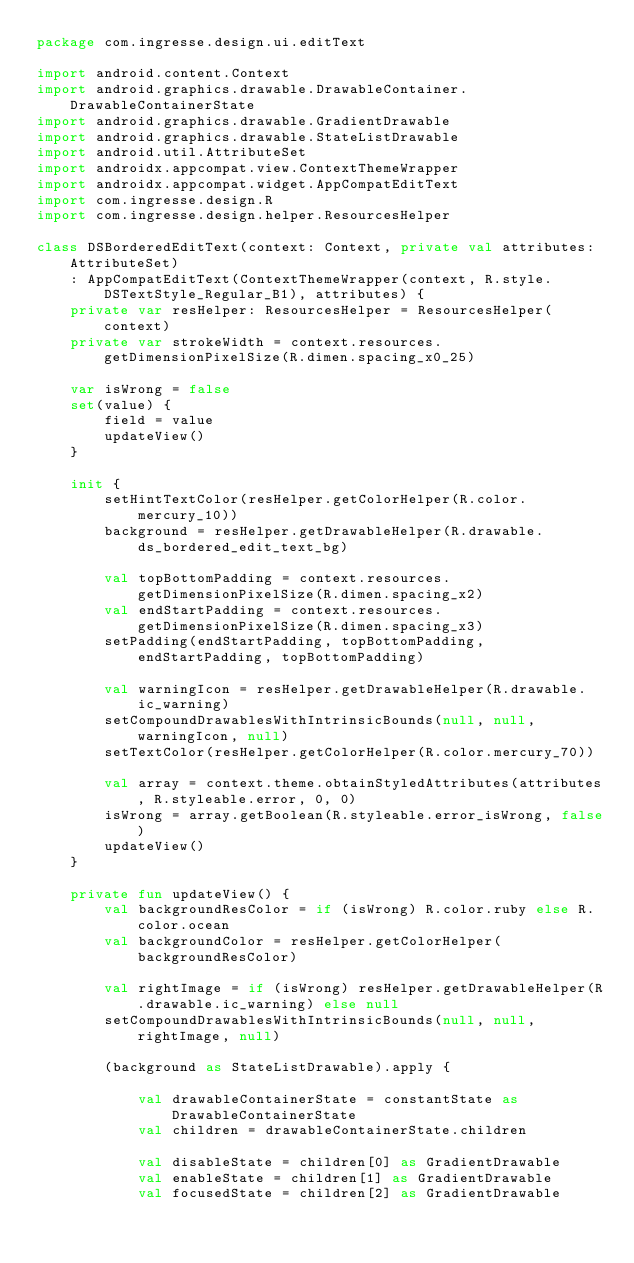Convert code to text. <code><loc_0><loc_0><loc_500><loc_500><_Kotlin_>package com.ingresse.design.ui.editText

import android.content.Context
import android.graphics.drawable.DrawableContainer.DrawableContainerState
import android.graphics.drawable.GradientDrawable
import android.graphics.drawable.StateListDrawable
import android.util.AttributeSet
import androidx.appcompat.view.ContextThemeWrapper
import androidx.appcompat.widget.AppCompatEditText
import com.ingresse.design.R
import com.ingresse.design.helper.ResourcesHelper

class DSBorderedEditText(context: Context, private val attributes: AttributeSet)
    : AppCompatEditText(ContextThemeWrapper(context, R.style.DSTextStyle_Regular_B1), attributes) {
    private var resHelper: ResourcesHelper = ResourcesHelper(context)
    private var strokeWidth = context.resources.getDimensionPixelSize(R.dimen.spacing_x0_25)

    var isWrong = false
    set(value) {
        field = value
        updateView()
    }

    init {
        setHintTextColor(resHelper.getColorHelper(R.color.mercury_10))
        background = resHelper.getDrawableHelper(R.drawable.ds_bordered_edit_text_bg)

        val topBottomPadding = context.resources.getDimensionPixelSize(R.dimen.spacing_x2)
        val endStartPadding = context.resources.getDimensionPixelSize(R.dimen.spacing_x3)
        setPadding(endStartPadding, topBottomPadding, endStartPadding, topBottomPadding)

        val warningIcon = resHelper.getDrawableHelper(R.drawable.ic_warning)
        setCompoundDrawablesWithIntrinsicBounds(null, null, warningIcon, null)
        setTextColor(resHelper.getColorHelper(R.color.mercury_70))

        val array = context.theme.obtainStyledAttributes(attributes, R.styleable.error, 0, 0)
        isWrong = array.getBoolean(R.styleable.error_isWrong, false)
        updateView()
    }

    private fun updateView() {
        val backgroundResColor = if (isWrong) R.color.ruby else R.color.ocean
        val backgroundColor = resHelper.getColorHelper(backgroundResColor)

        val rightImage = if (isWrong) resHelper.getDrawableHelper(R.drawable.ic_warning) else null
        setCompoundDrawablesWithIntrinsicBounds(null, null, rightImage, null)

        (background as StateListDrawable).apply {

            val drawableContainerState = constantState as DrawableContainerState
            val children = drawableContainerState.children

            val disableState = children[0] as GradientDrawable
            val enableState = children[1] as GradientDrawable
            val focusedState = children[2] as GradientDrawable
</code> 